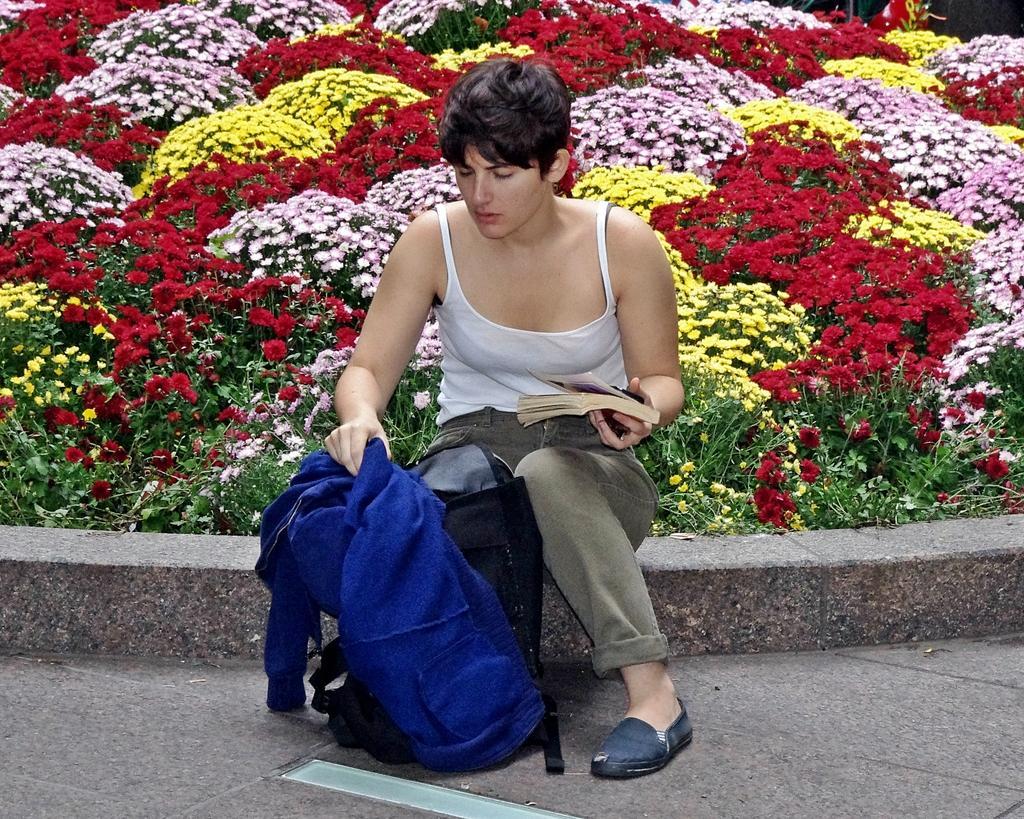Could you give a brief overview of what you see in this image? In this image in the center there is one person sitting and she is holding a book and jacket, and there is one bag. At the bottom there is walkway, in the background there are some plants and flowers. 